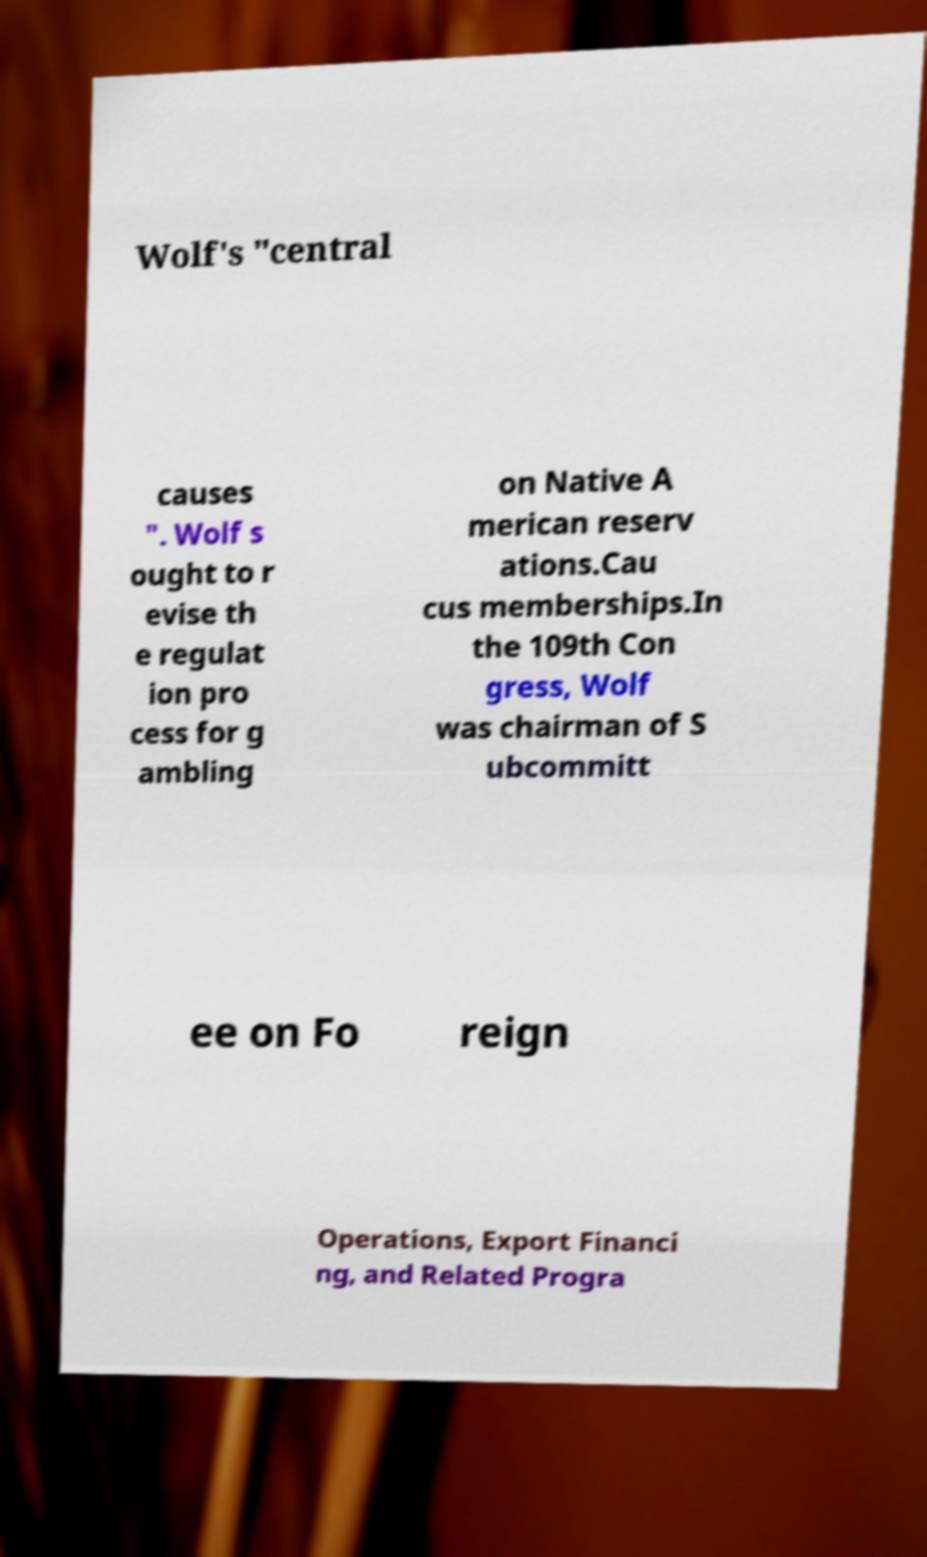Could you assist in decoding the text presented in this image and type it out clearly? Wolf's "central causes ". Wolf s ought to r evise th e regulat ion pro cess for g ambling on Native A merican reserv ations.Cau cus memberships.In the 109th Con gress, Wolf was chairman of S ubcommitt ee on Fo reign Operations, Export Financi ng, and Related Progra 